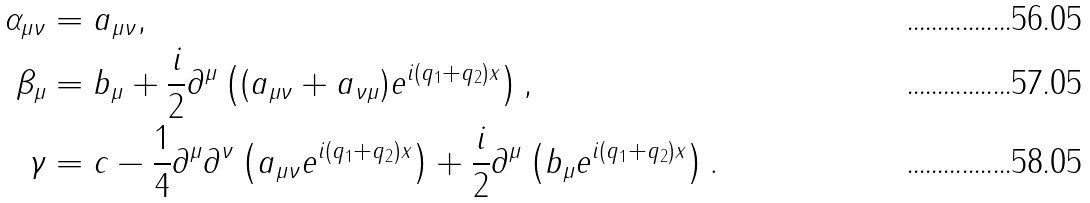Convert formula to latex. <formula><loc_0><loc_0><loc_500><loc_500>\alpha _ { \mu \nu } & = a _ { \mu \nu } , \\ \beta _ { \mu } & = b _ { \mu } + \frac { i } { 2 } \partial ^ { \mu } \left ( ( a _ { \mu \nu } + a _ { \nu \mu } ) e ^ { i ( q _ { 1 } + q _ { 2 } ) x } \right ) , \\ \gamma & = c - \frac { 1 } { 4 } \partial ^ { \mu } \partial ^ { \nu } \left ( a _ { \mu \nu } e ^ { i ( q _ { 1 } + q _ { 2 } ) x } \right ) + \frac { i } { 2 } \partial ^ { \mu } \left ( b _ { \mu } e ^ { i ( q _ { 1 } + q _ { 2 } ) x } \right ) .</formula> 